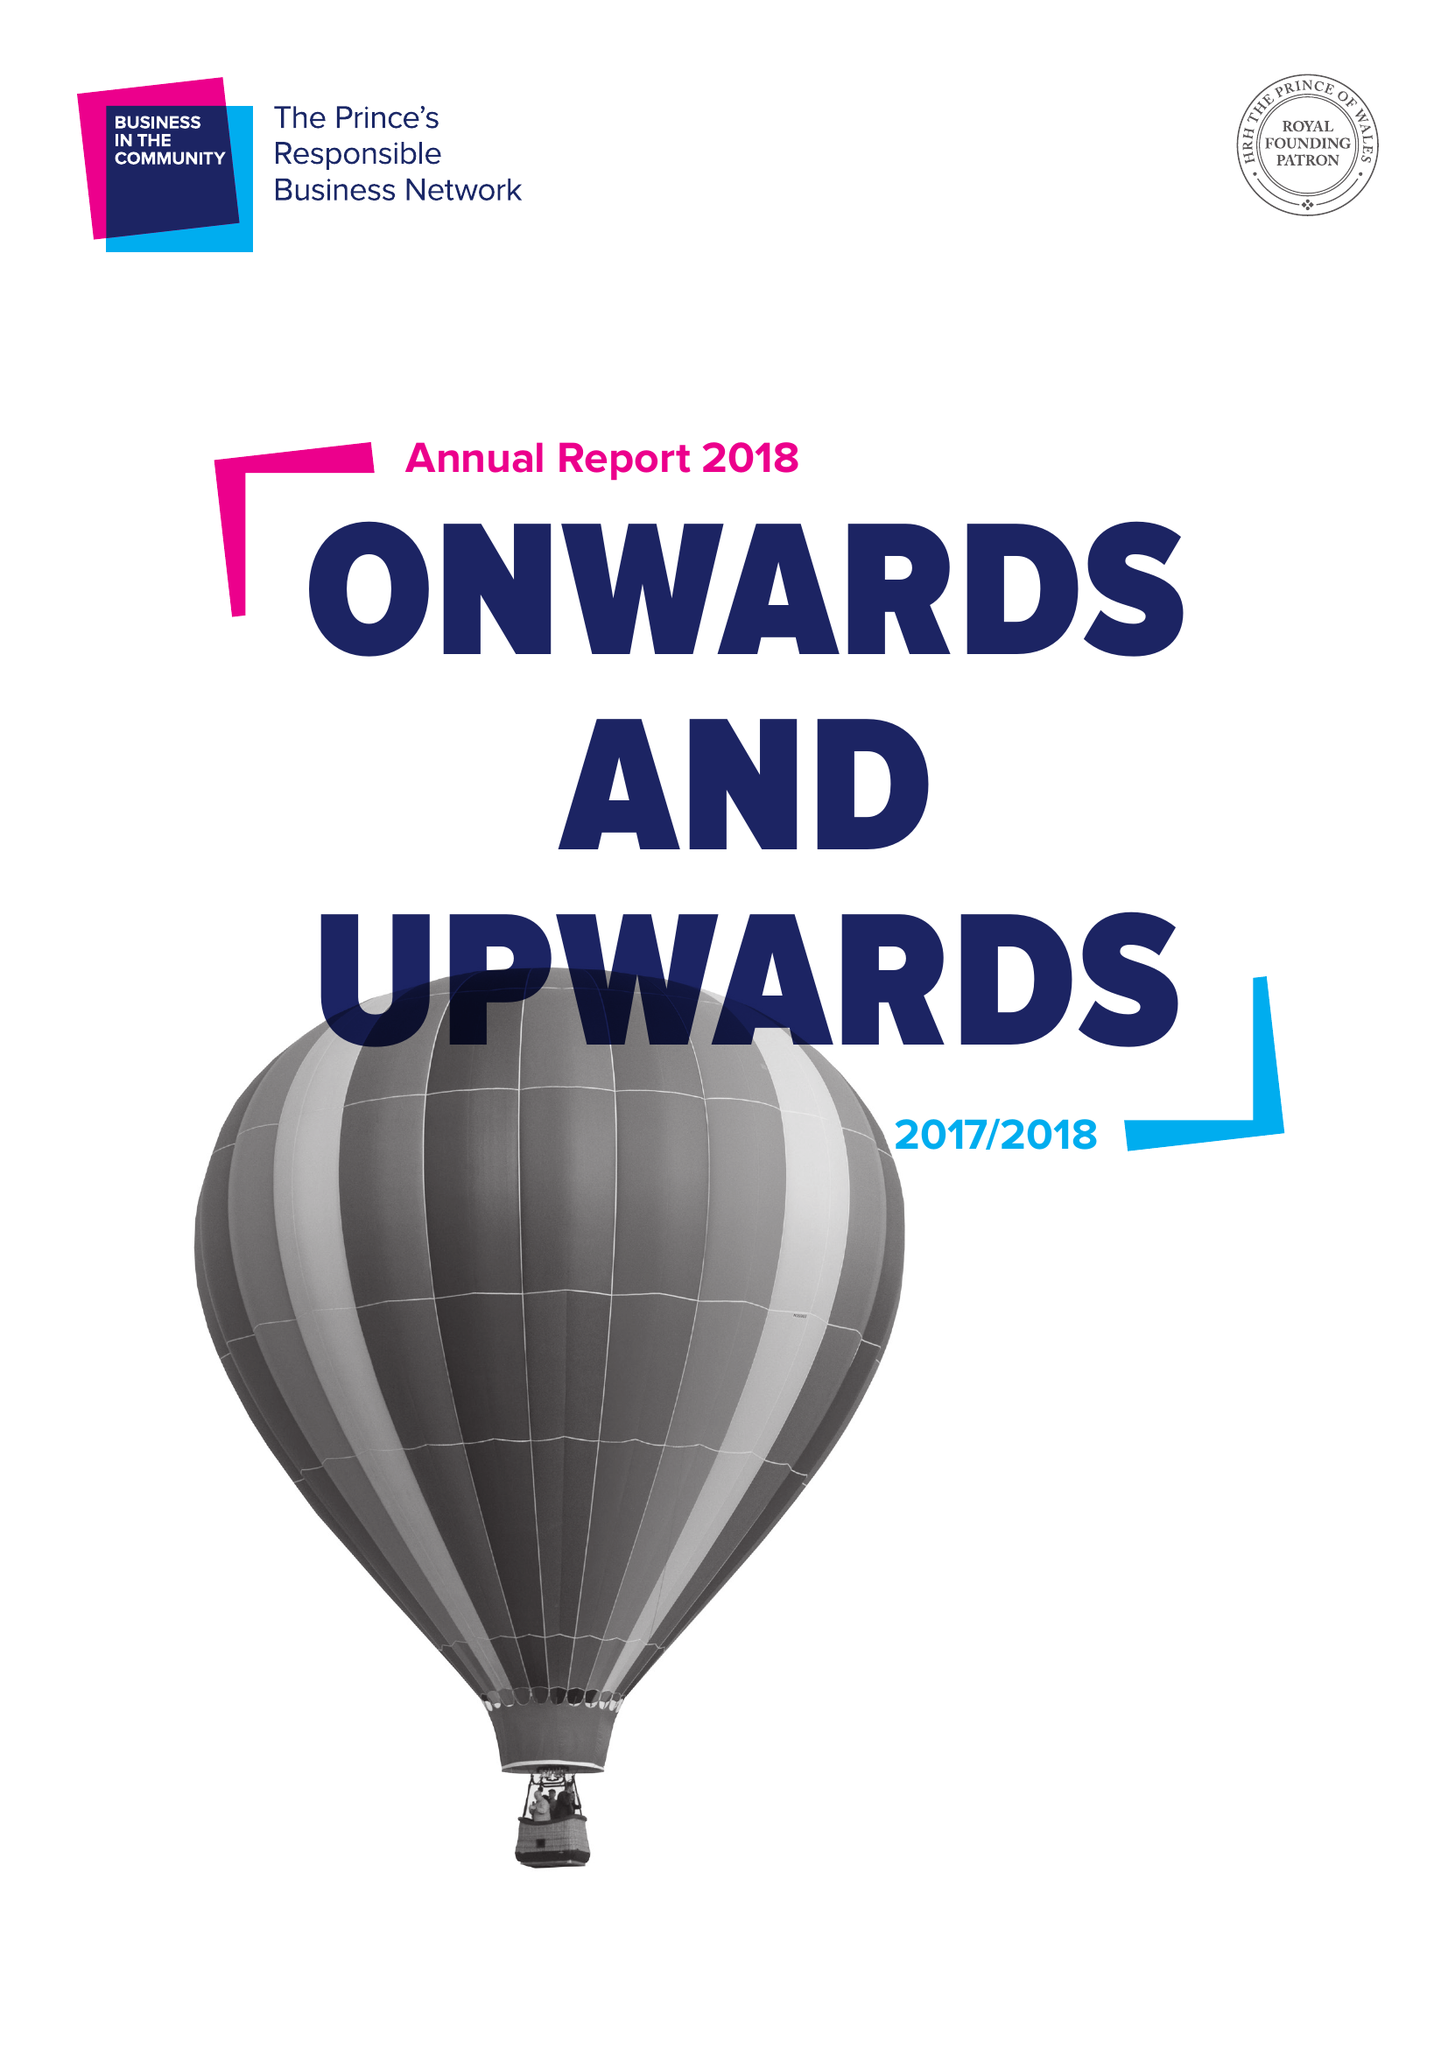What is the value for the charity_name?
Answer the question using a single word or phrase. Business In The Community 